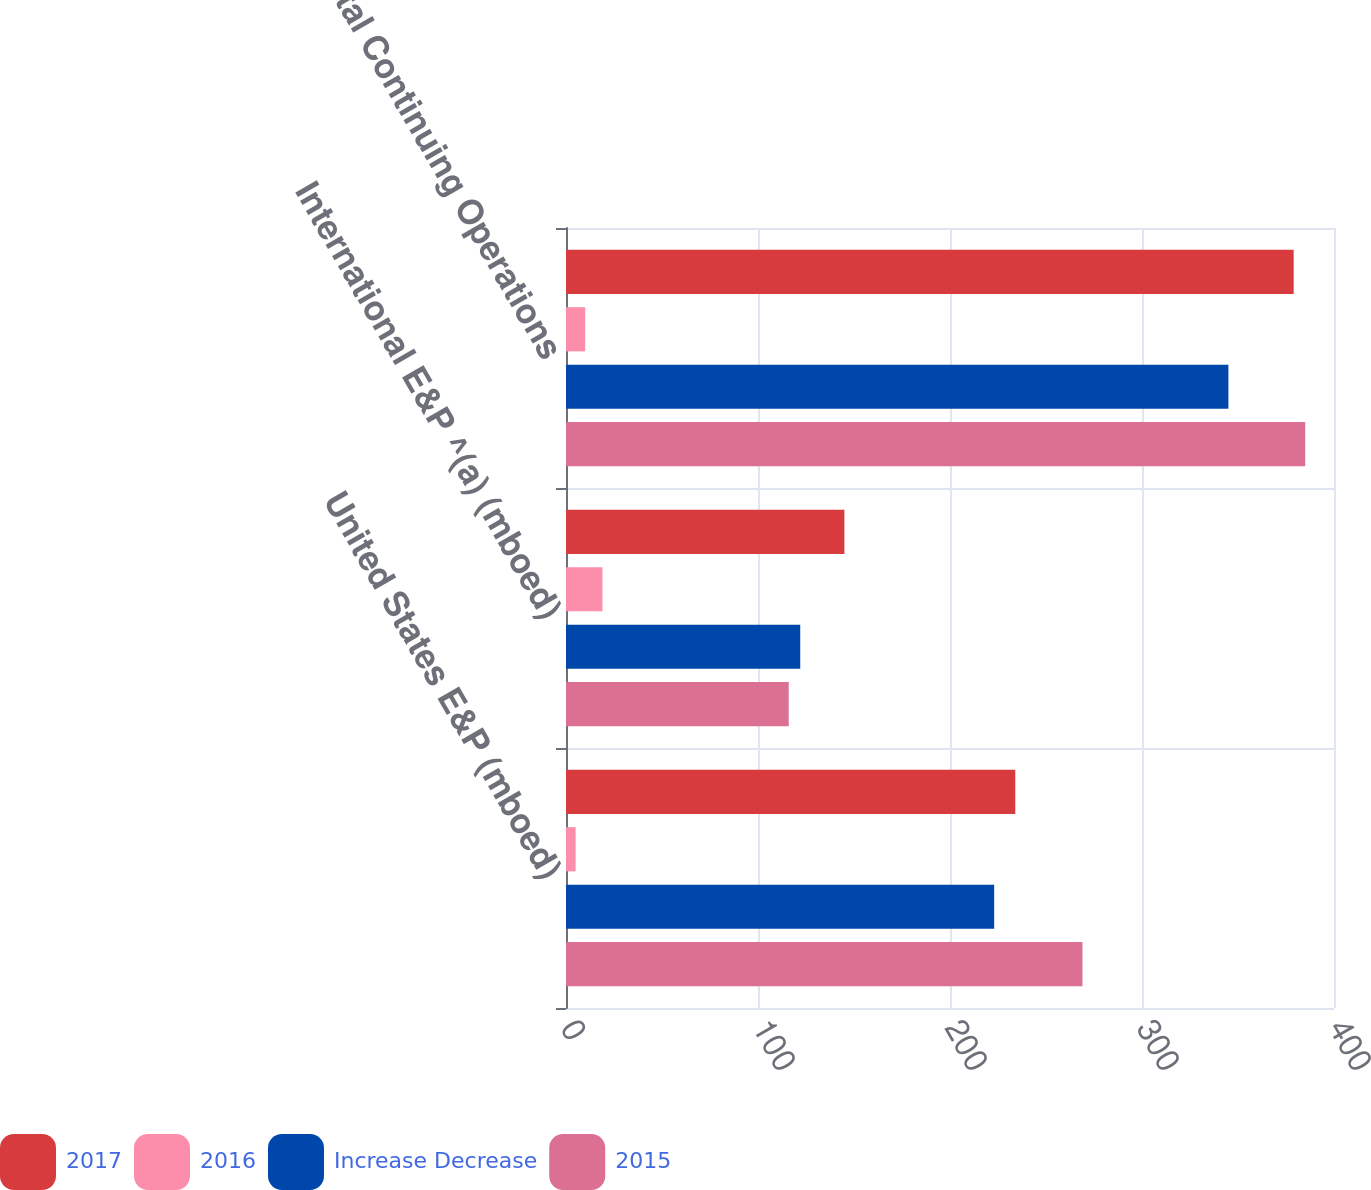Convert chart to OTSL. <chart><loc_0><loc_0><loc_500><loc_500><stacked_bar_chart><ecel><fcel>United States E&P (mboed)<fcel>International E&P ^(a) (mboed)<fcel>Total Continuing Operations<nl><fcel>2017<fcel>234<fcel>145<fcel>379<nl><fcel>2016<fcel>5<fcel>19<fcel>10<nl><fcel>Increase Decrease<fcel>223<fcel>122<fcel>345<nl><fcel>2015<fcel>269<fcel>116<fcel>385<nl></chart> 